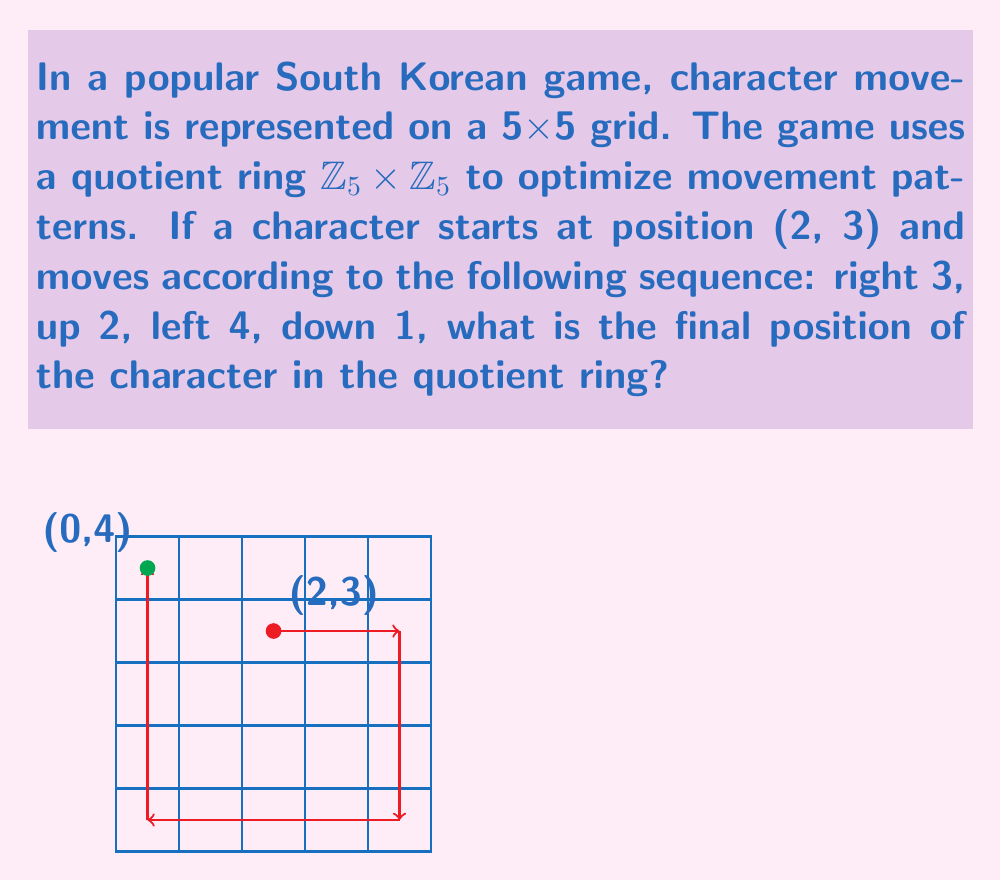Provide a solution to this math problem. Let's break this down step-by-step:

1) The initial position is (2, 3) in $\mathbb{Z}_5 \times \mathbb{Z}_5$.

2) Moving right 3:
   $(2+3, 3) = (5, 3) \equiv (0, 3) \pmod{5}$

3) Moving up 2:
   $(0, 3+2) = (0, 5) \equiv (0, 0) \pmod{5}$

4) Moving left 4:
   In $\mathbb{Z}_5$, moving left 4 is equivalent to moving right 1.
   $(0+1, 0) = (1, 0) \pmod{5}$

5) Moving down 1:
   $(1, 0-1) = (1, -1) \equiv (1, 4) \pmod{5}$

Therefore, the final position in $\mathbb{Z}_5 \times \mathbb{Z}_5$ is (1, 4).

However, as the question asks for the position in the quotient ring, we need to consider that (1, 4) is equivalent to (0, 4) in the 5x5 grid representation.
Answer: (0, 4) 